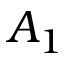<formula> <loc_0><loc_0><loc_500><loc_500>A _ { 1 }</formula> 